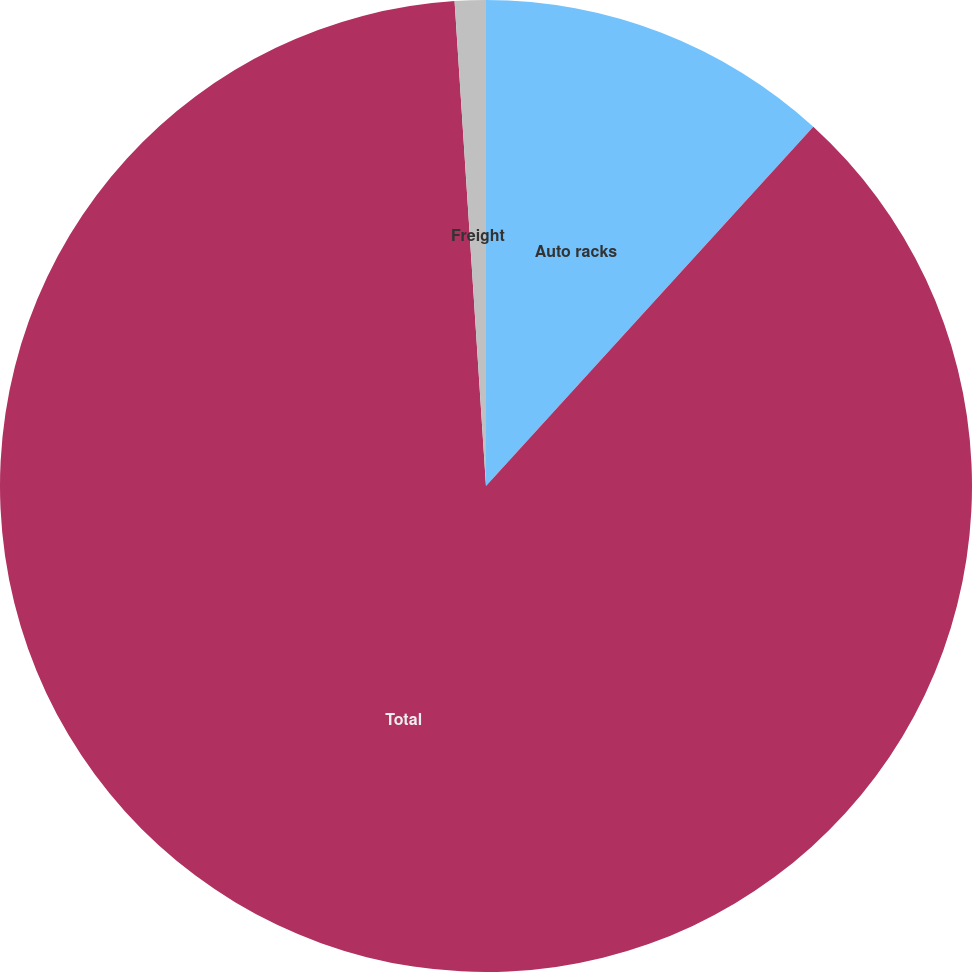<chart> <loc_0><loc_0><loc_500><loc_500><pie_chart><fcel>Auto racks<fcel>Total<fcel>Freight<nl><fcel>11.76%<fcel>87.21%<fcel>1.03%<nl></chart> 